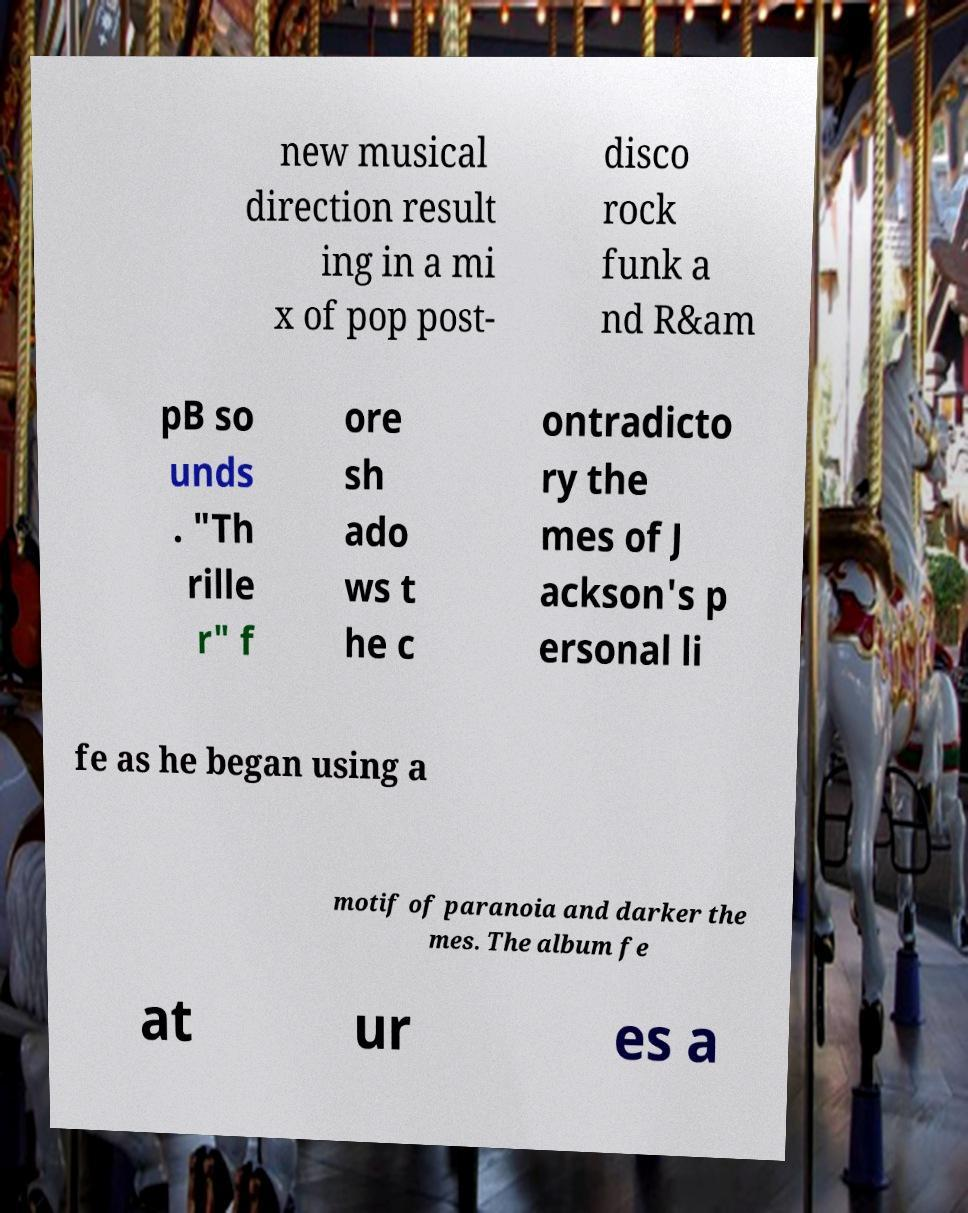Please identify and transcribe the text found in this image. new musical direction result ing in a mi x of pop post- disco rock funk a nd R&am pB so unds . "Th rille r" f ore sh ado ws t he c ontradicto ry the mes of J ackson's p ersonal li fe as he began using a motif of paranoia and darker the mes. The album fe at ur es a 